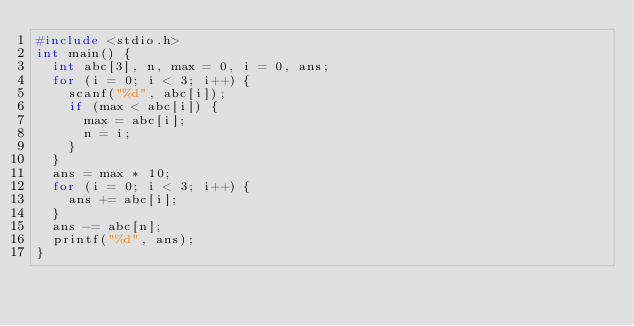<code> <loc_0><loc_0><loc_500><loc_500><_C_>#include <stdio.h>
int main() {
  int abc[3], n, max = 0, i = 0, ans;
  for (i = 0; i < 3; i++) {
    scanf("%d", abc[i]);
    if (max < abc[i]) {
      max = abc[i];
      n = i;
    }
  }
  ans = max * 10;
  for (i = 0; i < 3; i++) {
    ans += abc[i];
  }
  ans -= abc[n];
  printf("%d", ans);
}</code> 